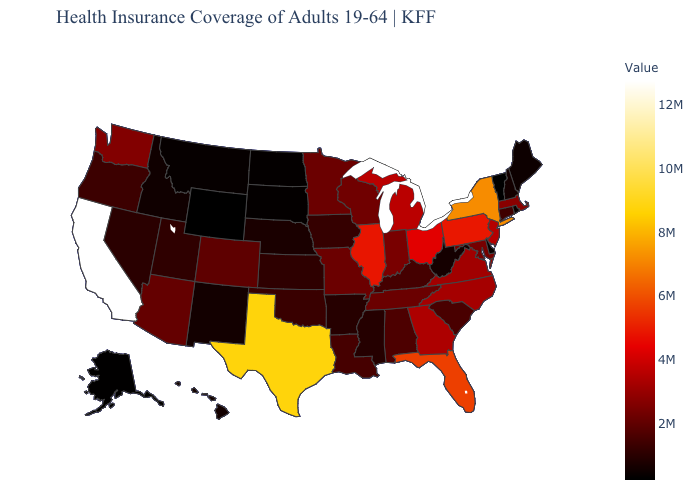Which states hav the highest value in the West?
Short answer required. California. Does the map have missing data?
Give a very brief answer. No. Among the states that border Pennsylvania , does New Jersey have the lowest value?
Concise answer only. No. Which states have the lowest value in the USA?
Keep it brief. Wyoming. Does the map have missing data?
Quick response, please. No. Is the legend a continuous bar?
Quick response, please. Yes. 